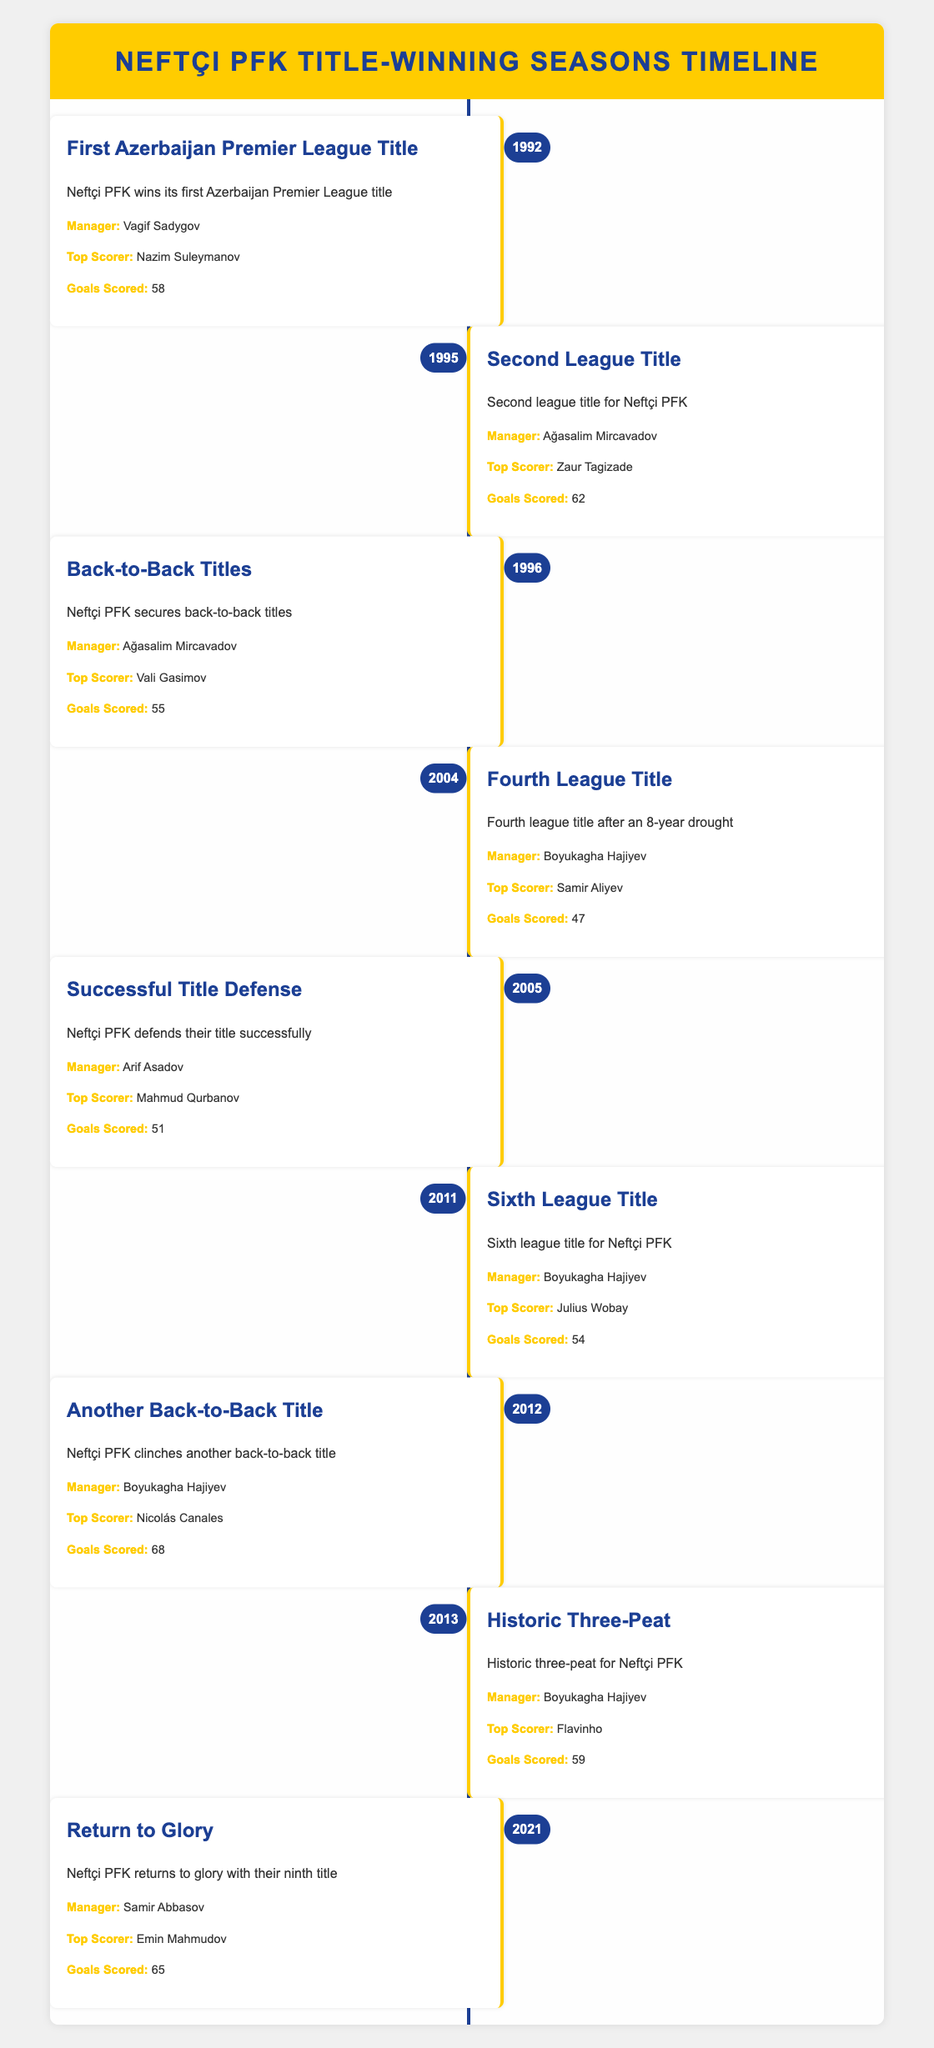What year did Neftçi PFK win their first league title? The table indicates that Neftçi PFK won their first Azerbaijan Premier League title in 1992.
Answer: 1992 Who was the top scorer for Neftçi PFK in their 2005 title-winning season? In the timeline, the entry for 2005 lists Mahmud Qurbanov as the top scorer.
Answer: Mahmud Qurbanov How many goals did Neftçi PFK score in 2012? According to the 2012 entry in the table, Neftçi PFK scored 68 goals that season.
Answer: 68 What was the difference in the number of goals scored between the 1995 and 2004 seasons? Neftçi PFK scored 62 goals in 1995 and 47 goals in 2004. The difference is 62 - 47 = 15.
Answer: 15 Did Neftçi PFK achieve back-to-back titles in the years recorded? Yes, the table shows that Neftçi PFK secured back-to-back titles in 1996 and again in 2012.
Answer: Yes Which manager led Neftçi PFK during their last title in 2021? The timeline states that Samir Abbasov was the manager for the 2021 title-winning season.
Answer: Samir Abbasov Which season had the highest number of goals scored by Neftçi PFK? By looking through the table, the 2012 season had the highest number of goals scored, 68.
Answer: 2012 How many league titles did Neftçi PFK win between 1992 and 2013? From the timeline, Neftçi PFK won a total of 6 league titles between 1992 and 2013 (1992, 1995, 1996, 2004, 2005, 2011, 2012, 2013).
Answer: 6 What is the average number of goals scored in the title-winning seasons from 1992 to 2021? Totaling the goals: 58 + 62 + 55 + 47 + 51 + 54 + 68 + 59 + 65 =  465. The total number of seasons is 9, so the average is 465/9 = 51.67.
Answer: 51.67 